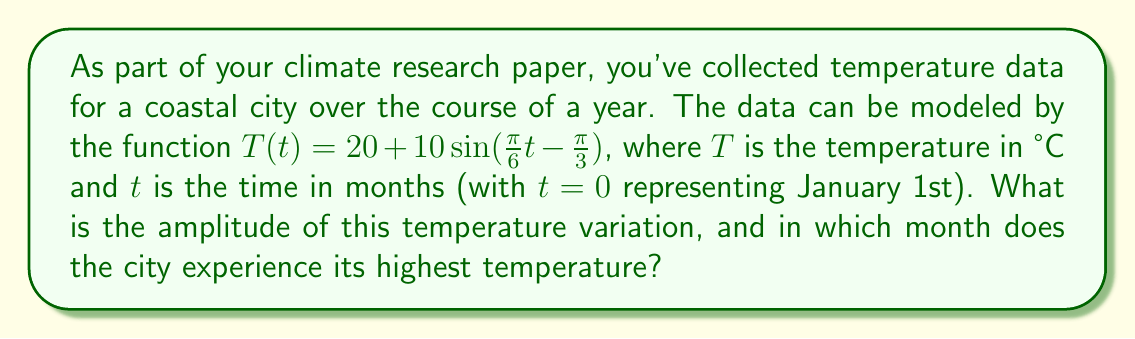Solve this math problem. Let's approach this step-by-step:

1) The general form of a sine function is:
   $$ f(t) = A\sin(Bt - C) + D $$
   where $A$ is the amplitude, $B$ is the frequency, $C$ is the phase shift, and $D$ is the vertical shift.

2) Comparing our function to the general form:
   $$ T(t) = 20 + 10\sin(\frac{\pi}{6}t - \frac{\pi}{3}) $$
   We can see that $A = 10$, $B = \frac{\pi}{6}$, $C = \frac{\pi}{3}$, and $D = 20$.

3) The amplitude is the value of $A$, which is 10°C.

4) To find the month with the highest temperature, we need to solve:
   $$ \frac{\pi}{6}t - \frac{\pi}{3} = \frac{\pi}{2} $$
   This is because sine reaches its maximum at $\frac{\pi}{2}$.

5) Solving the equation:
   $$ \frac{\pi}{6}t = \frac{\pi}{2} + \frac{\pi}{3} = \frac{5\pi}{6} $$
   $$ t = 5 $$

6) Since $t=0$ represents January 1st, $t=5$ represents June.

Therefore, the amplitude of the temperature variation is 10°C, and the city experiences its highest temperature in June.
Answer: Amplitude: 10°C; Highest temperature: June 